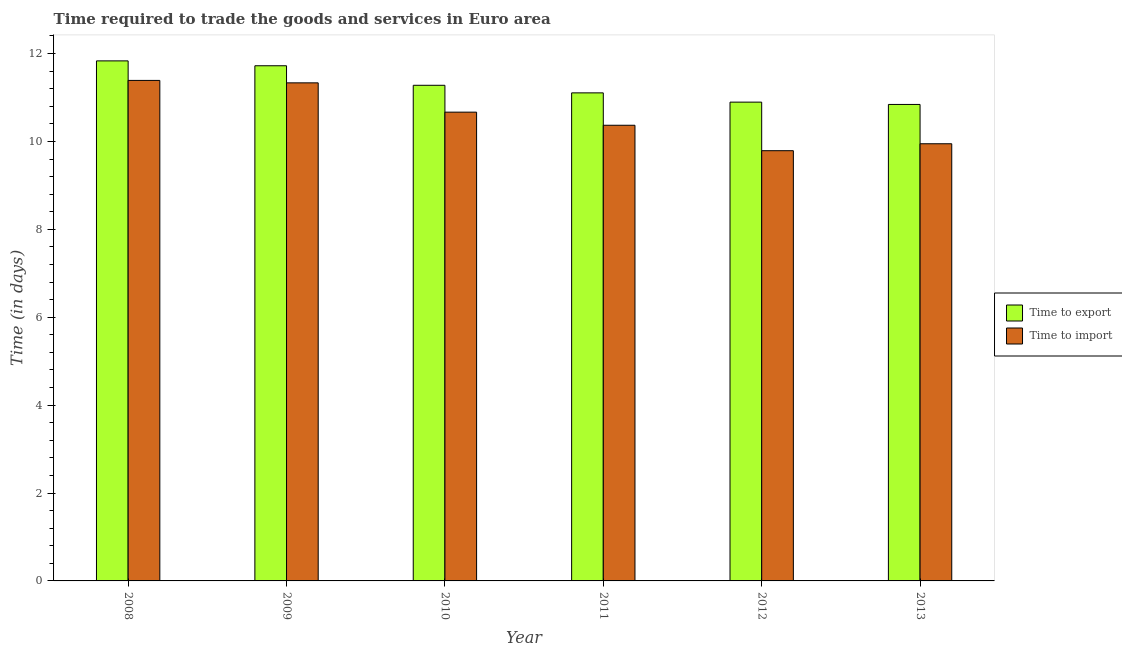Are the number of bars on each tick of the X-axis equal?
Ensure brevity in your answer.  Yes. What is the label of the 1st group of bars from the left?
Provide a succinct answer. 2008. In how many cases, is the number of bars for a given year not equal to the number of legend labels?
Provide a succinct answer. 0. What is the time to export in 2013?
Your answer should be compact. 10.84. Across all years, what is the maximum time to export?
Offer a terse response. 11.83. Across all years, what is the minimum time to import?
Keep it short and to the point. 9.79. In which year was the time to export maximum?
Your response must be concise. 2008. In which year was the time to import minimum?
Give a very brief answer. 2012. What is the total time to import in the graph?
Make the answer very short. 63.49. What is the difference between the time to export in 2009 and that in 2011?
Your response must be concise. 0.62. What is the difference between the time to export in 2012 and the time to import in 2008?
Make the answer very short. -0.94. What is the average time to import per year?
Your answer should be compact. 10.58. What is the ratio of the time to import in 2009 to that in 2011?
Ensure brevity in your answer.  1.09. Is the difference between the time to import in 2008 and 2012 greater than the difference between the time to export in 2008 and 2012?
Make the answer very short. No. What is the difference between the highest and the second highest time to import?
Your answer should be very brief. 0.06. What is the difference between the highest and the lowest time to import?
Provide a short and direct response. 1.6. What does the 1st bar from the left in 2009 represents?
Your response must be concise. Time to export. What does the 1st bar from the right in 2011 represents?
Provide a succinct answer. Time to import. How many bars are there?
Your response must be concise. 12. Are all the bars in the graph horizontal?
Provide a short and direct response. No. Where does the legend appear in the graph?
Keep it short and to the point. Center right. What is the title of the graph?
Provide a succinct answer. Time required to trade the goods and services in Euro area. Does "Male labor force" appear as one of the legend labels in the graph?
Offer a very short reply. No. What is the label or title of the Y-axis?
Ensure brevity in your answer.  Time (in days). What is the Time (in days) in Time to export in 2008?
Your answer should be very brief. 11.83. What is the Time (in days) in Time to import in 2008?
Keep it short and to the point. 11.39. What is the Time (in days) in Time to export in 2009?
Your response must be concise. 11.72. What is the Time (in days) in Time to import in 2009?
Provide a succinct answer. 11.33. What is the Time (in days) in Time to export in 2010?
Provide a short and direct response. 11.28. What is the Time (in days) in Time to import in 2010?
Give a very brief answer. 10.67. What is the Time (in days) in Time to export in 2011?
Provide a short and direct response. 11.11. What is the Time (in days) in Time to import in 2011?
Provide a short and direct response. 10.37. What is the Time (in days) in Time to export in 2012?
Provide a short and direct response. 10.89. What is the Time (in days) of Time to import in 2012?
Provide a succinct answer. 9.79. What is the Time (in days) in Time to export in 2013?
Keep it short and to the point. 10.84. What is the Time (in days) in Time to import in 2013?
Your answer should be compact. 9.95. Across all years, what is the maximum Time (in days) in Time to export?
Ensure brevity in your answer.  11.83. Across all years, what is the maximum Time (in days) in Time to import?
Make the answer very short. 11.39. Across all years, what is the minimum Time (in days) in Time to export?
Your response must be concise. 10.84. Across all years, what is the minimum Time (in days) in Time to import?
Provide a short and direct response. 9.79. What is the total Time (in days) of Time to export in the graph?
Keep it short and to the point. 67.68. What is the total Time (in days) of Time to import in the graph?
Offer a very short reply. 63.49. What is the difference between the Time (in days) in Time to import in 2008 and that in 2009?
Your response must be concise. 0.06. What is the difference between the Time (in days) of Time to export in 2008 and that in 2010?
Offer a very short reply. 0.56. What is the difference between the Time (in days) of Time to import in 2008 and that in 2010?
Offer a terse response. 0.72. What is the difference between the Time (in days) in Time to export in 2008 and that in 2011?
Your answer should be very brief. 0.73. What is the difference between the Time (in days) in Time to import in 2008 and that in 2011?
Keep it short and to the point. 1.02. What is the difference between the Time (in days) in Time to export in 2008 and that in 2012?
Give a very brief answer. 0.94. What is the difference between the Time (in days) of Time to import in 2008 and that in 2012?
Your response must be concise. 1.6. What is the difference between the Time (in days) in Time to import in 2008 and that in 2013?
Provide a short and direct response. 1.44. What is the difference between the Time (in days) of Time to export in 2009 and that in 2010?
Your answer should be compact. 0.44. What is the difference between the Time (in days) of Time to import in 2009 and that in 2010?
Your answer should be very brief. 0.67. What is the difference between the Time (in days) in Time to export in 2009 and that in 2011?
Make the answer very short. 0.62. What is the difference between the Time (in days) of Time to import in 2009 and that in 2011?
Your response must be concise. 0.96. What is the difference between the Time (in days) in Time to export in 2009 and that in 2012?
Offer a very short reply. 0.83. What is the difference between the Time (in days) in Time to import in 2009 and that in 2012?
Your response must be concise. 1.54. What is the difference between the Time (in days) in Time to export in 2009 and that in 2013?
Keep it short and to the point. 0.88. What is the difference between the Time (in days) of Time to import in 2009 and that in 2013?
Offer a very short reply. 1.39. What is the difference between the Time (in days) of Time to export in 2010 and that in 2011?
Provide a succinct answer. 0.17. What is the difference between the Time (in days) in Time to import in 2010 and that in 2011?
Ensure brevity in your answer.  0.3. What is the difference between the Time (in days) of Time to export in 2010 and that in 2012?
Your answer should be very brief. 0.38. What is the difference between the Time (in days) in Time to import in 2010 and that in 2012?
Keep it short and to the point. 0.88. What is the difference between the Time (in days) in Time to export in 2010 and that in 2013?
Ensure brevity in your answer.  0.44. What is the difference between the Time (in days) in Time to import in 2010 and that in 2013?
Provide a succinct answer. 0.72. What is the difference between the Time (in days) of Time to export in 2011 and that in 2012?
Your response must be concise. 0.21. What is the difference between the Time (in days) in Time to import in 2011 and that in 2012?
Provide a short and direct response. 0.58. What is the difference between the Time (in days) of Time to export in 2011 and that in 2013?
Your answer should be compact. 0.26. What is the difference between the Time (in days) of Time to import in 2011 and that in 2013?
Give a very brief answer. 0.42. What is the difference between the Time (in days) of Time to export in 2012 and that in 2013?
Keep it short and to the point. 0.05. What is the difference between the Time (in days) of Time to import in 2012 and that in 2013?
Offer a very short reply. -0.16. What is the difference between the Time (in days) of Time to export in 2008 and the Time (in days) of Time to import in 2010?
Make the answer very short. 1.17. What is the difference between the Time (in days) in Time to export in 2008 and the Time (in days) in Time to import in 2011?
Offer a very short reply. 1.46. What is the difference between the Time (in days) of Time to export in 2008 and the Time (in days) of Time to import in 2012?
Ensure brevity in your answer.  2.04. What is the difference between the Time (in days) of Time to export in 2008 and the Time (in days) of Time to import in 2013?
Ensure brevity in your answer.  1.89. What is the difference between the Time (in days) of Time to export in 2009 and the Time (in days) of Time to import in 2010?
Make the answer very short. 1.06. What is the difference between the Time (in days) of Time to export in 2009 and the Time (in days) of Time to import in 2011?
Ensure brevity in your answer.  1.35. What is the difference between the Time (in days) in Time to export in 2009 and the Time (in days) in Time to import in 2012?
Your answer should be compact. 1.93. What is the difference between the Time (in days) in Time to export in 2009 and the Time (in days) in Time to import in 2013?
Provide a succinct answer. 1.77. What is the difference between the Time (in days) of Time to export in 2010 and the Time (in days) of Time to import in 2011?
Give a very brief answer. 0.91. What is the difference between the Time (in days) in Time to export in 2010 and the Time (in days) in Time to import in 2012?
Give a very brief answer. 1.49. What is the difference between the Time (in days) in Time to export in 2010 and the Time (in days) in Time to import in 2013?
Your answer should be compact. 1.33. What is the difference between the Time (in days) in Time to export in 2011 and the Time (in days) in Time to import in 2012?
Give a very brief answer. 1.32. What is the difference between the Time (in days) of Time to export in 2011 and the Time (in days) of Time to import in 2013?
Offer a very short reply. 1.16. What is the difference between the Time (in days) in Time to export in 2012 and the Time (in days) in Time to import in 2013?
Provide a succinct answer. 0.95. What is the average Time (in days) in Time to export per year?
Provide a succinct answer. 11.28. What is the average Time (in days) in Time to import per year?
Provide a succinct answer. 10.58. In the year 2008, what is the difference between the Time (in days) of Time to export and Time (in days) of Time to import?
Your response must be concise. 0.44. In the year 2009, what is the difference between the Time (in days) in Time to export and Time (in days) in Time to import?
Your response must be concise. 0.39. In the year 2010, what is the difference between the Time (in days) in Time to export and Time (in days) in Time to import?
Your response must be concise. 0.61. In the year 2011, what is the difference between the Time (in days) in Time to export and Time (in days) in Time to import?
Your answer should be compact. 0.74. In the year 2012, what is the difference between the Time (in days) of Time to export and Time (in days) of Time to import?
Make the answer very short. 1.11. In the year 2013, what is the difference between the Time (in days) of Time to export and Time (in days) of Time to import?
Provide a succinct answer. 0.89. What is the ratio of the Time (in days) in Time to export in 2008 to that in 2009?
Give a very brief answer. 1.01. What is the ratio of the Time (in days) in Time to export in 2008 to that in 2010?
Ensure brevity in your answer.  1.05. What is the ratio of the Time (in days) of Time to import in 2008 to that in 2010?
Ensure brevity in your answer.  1.07. What is the ratio of the Time (in days) of Time to export in 2008 to that in 2011?
Your answer should be compact. 1.07. What is the ratio of the Time (in days) of Time to import in 2008 to that in 2011?
Offer a terse response. 1.1. What is the ratio of the Time (in days) of Time to export in 2008 to that in 2012?
Give a very brief answer. 1.09. What is the ratio of the Time (in days) in Time to import in 2008 to that in 2012?
Make the answer very short. 1.16. What is the ratio of the Time (in days) of Time to export in 2008 to that in 2013?
Offer a very short reply. 1.09. What is the ratio of the Time (in days) in Time to import in 2008 to that in 2013?
Provide a short and direct response. 1.14. What is the ratio of the Time (in days) of Time to export in 2009 to that in 2010?
Ensure brevity in your answer.  1.04. What is the ratio of the Time (in days) of Time to export in 2009 to that in 2011?
Offer a very short reply. 1.06. What is the ratio of the Time (in days) in Time to import in 2009 to that in 2011?
Provide a succinct answer. 1.09. What is the ratio of the Time (in days) of Time to export in 2009 to that in 2012?
Offer a terse response. 1.08. What is the ratio of the Time (in days) of Time to import in 2009 to that in 2012?
Your response must be concise. 1.16. What is the ratio of the Time (in days) of Time to export in 2009 to that in 2013?
Your answer should be compact. 1.08. What is the ratio of the Time (in days) in Time to import in 2009 to that in 2013?
Your answer should be very brief. 1.14. What is the ratio of the Time (in days) in Time to export in 2010 to that in 2011?
Provide a short and direct response. 1.02. What is the ratio of the Time (in days) in Time to import in 2010 to that in 2011?
Keep it short and to the point. 1.03. What is the ratio of the Time (in days) of Time to export in 2010 to that in 2012?
Ensure brevity in your answer.  1.04. What is the ratio of the Time (in days) in Time to import in 2010 to that in 2012?
Your answer should be very brief. 1.09. What is the ratio of the Time (in days) in Time to export in 2010 to that in 2013?
Your answer should be very brief. 1.04. What is the ratio of the Time (in days) of Time to import in 2010 to that in 2013?
Offer a terse response. 1.07. What is the ratio of the Time (in days) in Time to export in 2011 to that in 2012?
Give a very brief answer. 1.02. What is the ratio of the Time (in days) in Time to import in 2011 to that in 2012?
Your answer should be very brief. 1.06. What is the ratio of the Time (in days) in Time to export in 2011 to that in 2013?
Keep it short and to the point. 1.02. What is the ratio of the Time (in days) in Time to import in 2011 to that in 2013?
Make the answer very short. 1.04. What is the ratio of the Time (in days) in Time to export in 2012 to that in 2013?
Keep it short and to the point. 1. What is the ratio of the Time (in days) in Time to import in 2012 to that in 2013?
Make the answer very short. 0.98. What is the difference between the highest and the second highest Time (in days) in Time to export?
Ensure brevity in your answer.  0.11. What is the difference between the highest and the second highest Time (in days) in Time to import?
Keep it short and to the point. 0.06. What is the difference between the highest and the lowest Time (in days) of Time to import?
Ensure brevity in your answer.  1.6. 